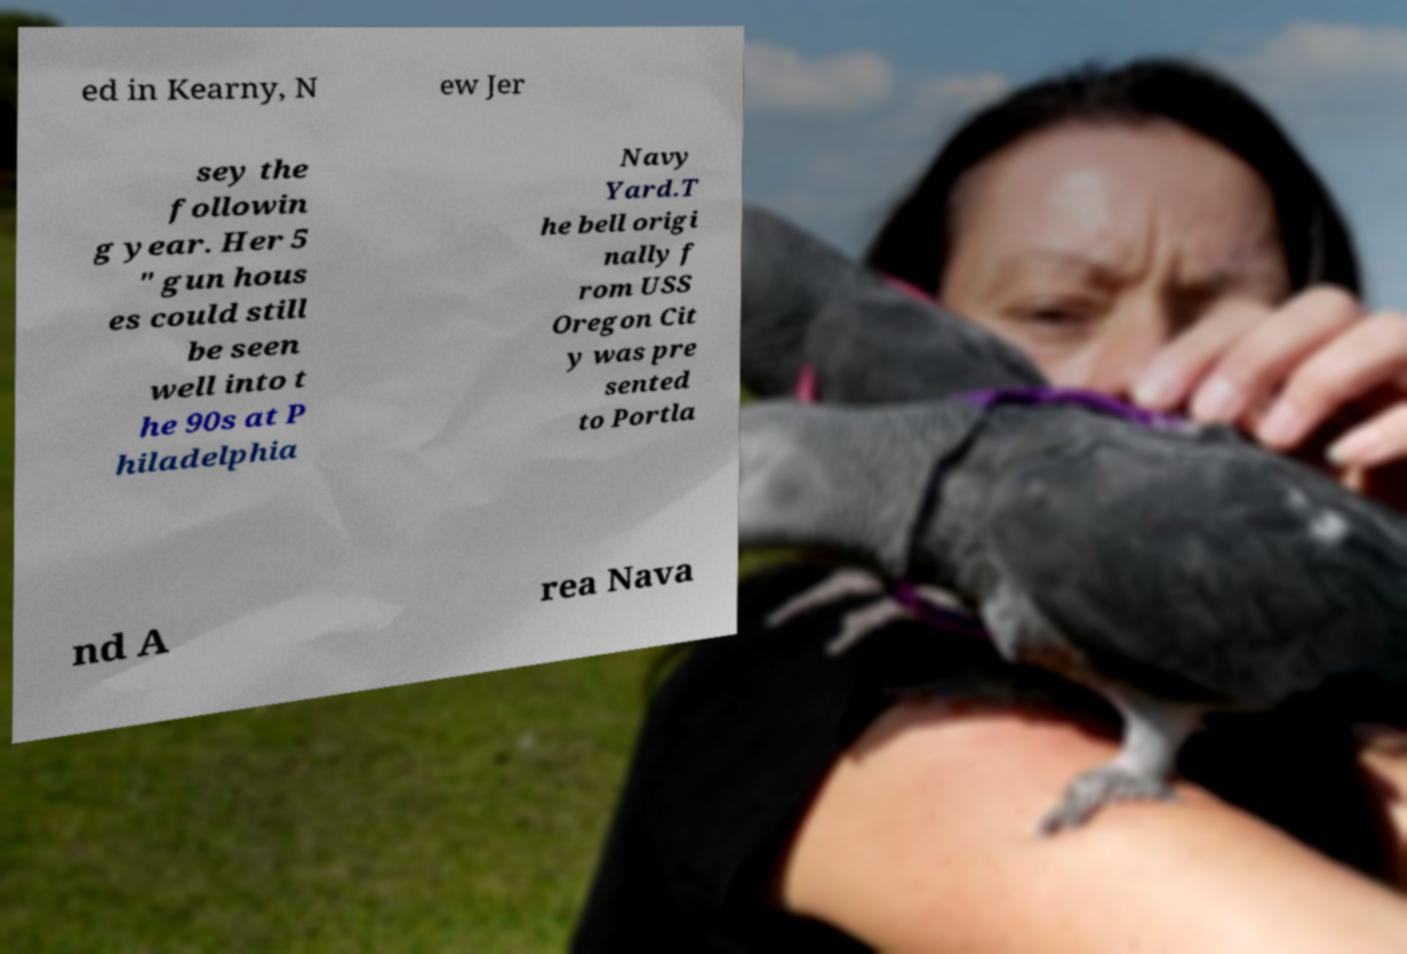For documentation purposes, I need the text within this image transcribed. Could you provide that? ed in Kearny, N ew Jer sey the followin g year. Her 5 " gun hous es could still be seen well into t he 90s at P hiladelphia Navy Yard.T he bell origi nally f rom USS Oregon Cit y was pre sented to Portla nd A rea Nava 